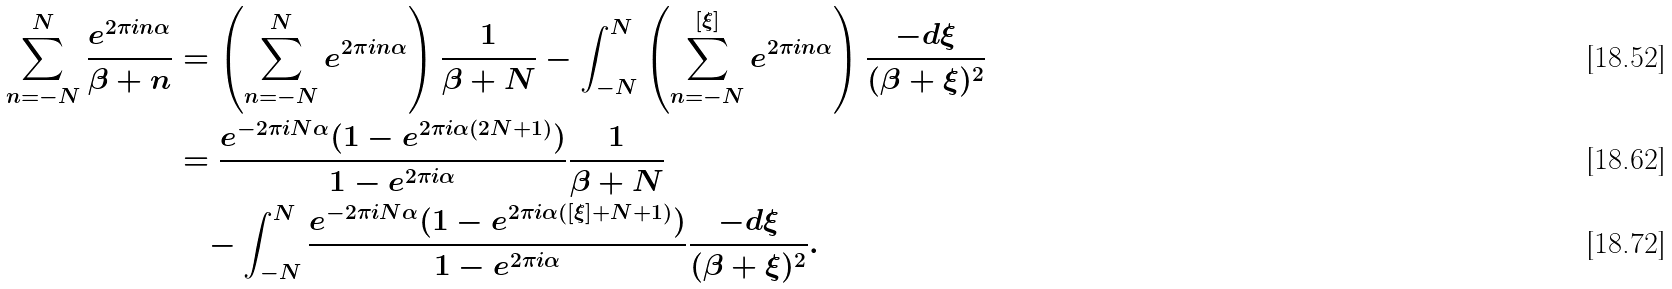Convert formula to latex. <formula><loc_0><loc_0><loc_500><loc_500>\sum _ { n = - N } ^ { N } \frac { e ^ { 2 \pi i n \alpha } } { \beta + n } & = \left ( \sum _ { n = - N } ^ { N } e ^ { 2 \pi i n \alpha } \right ) \frac { 1 } { \beta + N } - \int _ { - N } ^ { N } \left ( \sum _ { n = - N } ^ { [ \xi ] } e ^ { 2 \pi i n \alpha } \right ) \frac { - d \xi } { ( \beta + \xi ) ^ { 2 } } \\ & = \frac { e ^ { - 2 \pi i N \alpha } ( 1 - e ^ { 2 \pi i \alpha ( 2 N + 1 ) } ) } { 1 - e ^ { 2 \pi i \alpha } } \frac { 1 } { \beta + N } \\ & \quad - \int _ { - N } ^ { N } \frac { e ^ { - 2 \pi i N \alpha } ( 1 - e ^ { 2 \pi i \alpha ( [ \xi ] + N + 1 ) } ) } { 1 - e ^ { 2 \pi i \alpha } } \frac { - d \xi } { ( \beta + \xi ) ^ { 2 } } .</formula> 